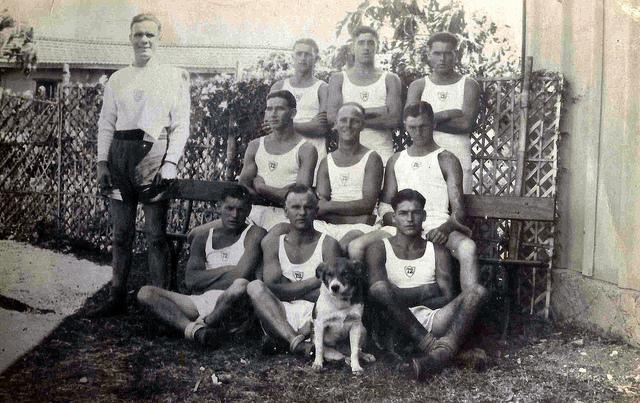What type of tops are the men on the right wearing? Please explain your reasoning. tank tops. They have no sleeves and have straps 